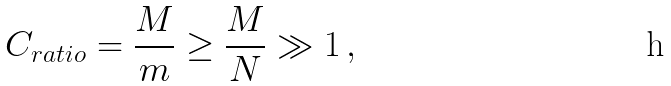Convert formula to latex. <formula><loc_0><loc_0><loc_500><loc_500>C _ { r a t i o } = \frac { M } { m } \geq \frac { M } { N } \gg 1 \, ,</formula> 